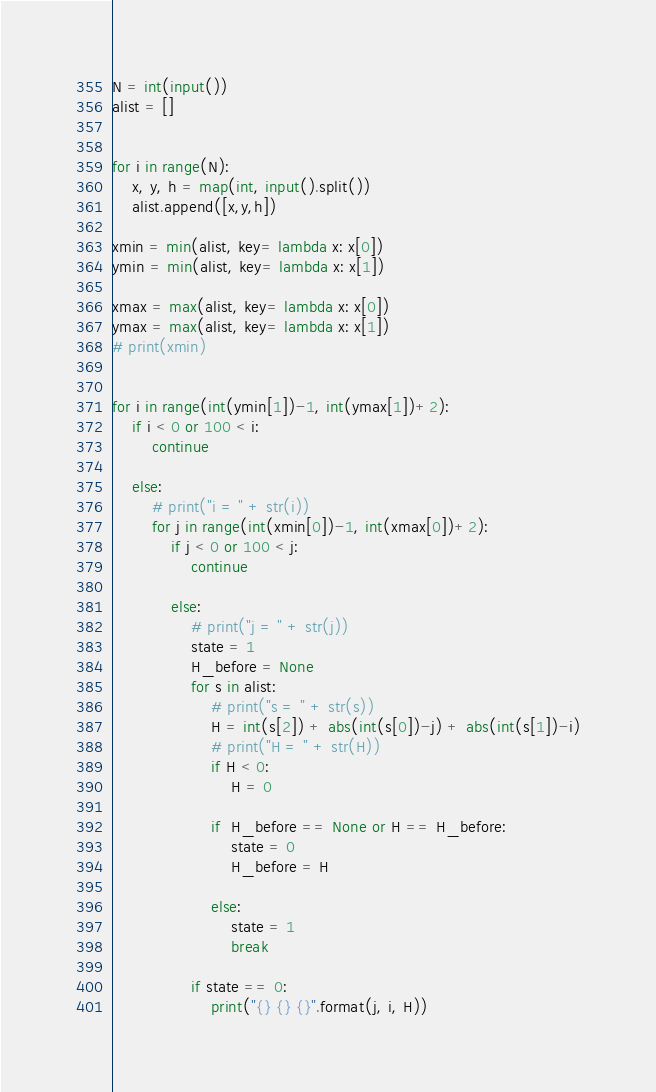Convert code to text. <code><loc_0><loc_0><loc_500><loc_500><_Python_>N = int(input())
alist = []


for i in range(N):
    x, y, h = map(int, input().split())
    alist.append([x,y,h])

xmin = min(alist, key= lambda x: x[0])
ymin = min(alist, key= lambda x: x[1])

xmax = max(alist, key= lambda x: x[0])
ymax = max(alist, key= lambda x: x[1])
# print(xmin)


for i in range(int(ymin[1])-1, int(ymax[1])+2):
    if i < 0 or 100 < i:
        continue

    else:
        # print("i = " + str(i))
        for j in range(int(xmin[0])-1, int(xmax[0])+2):
            if j < 0 or 100 < j:
                continue
            
            else:
                # print("j = " + str(j))
                state = 1
                H_before = None
                for s in alist:
                    # print("s = " + str(s))
                    H = int(s[2]) + abs(int(s[0])-j) + abs(int(s[1])-i)
                    # print("H = " + str(H))
                    if H < 0:
                        H = 0
                    
                    if  H_before == None or H == H_before:
                        state = 0
                        H_before = H
                    
                    else:
                        state = 1
                        break
                
                if state == 0:
                    print("{} {} {}".format(j, i, H))</code> 